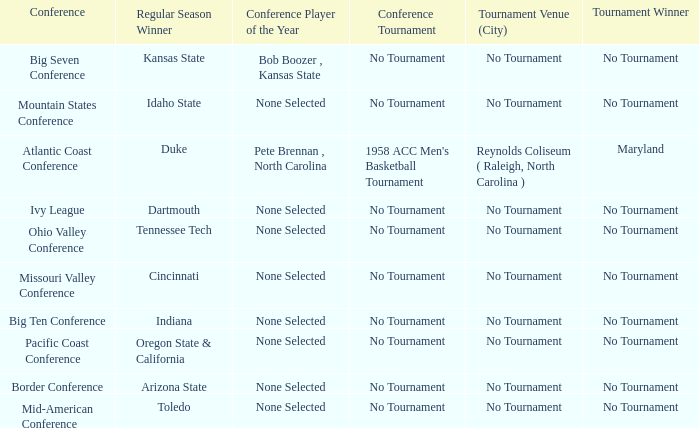What was the conference when Arizona State won the regular season? Border Conference. 